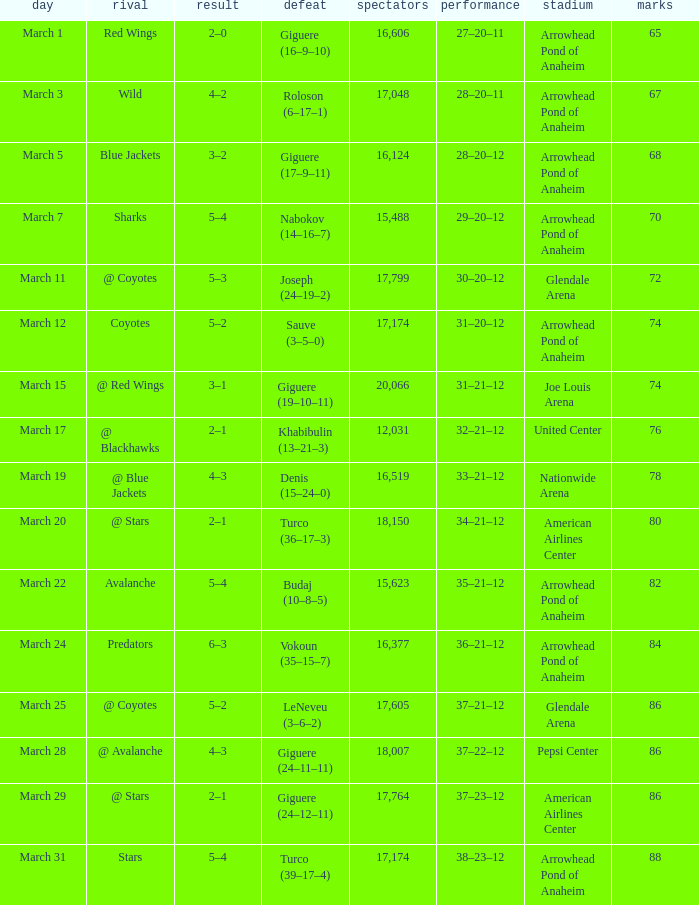What is the Attendance of the game with a Score of 3–2? 1.0. 